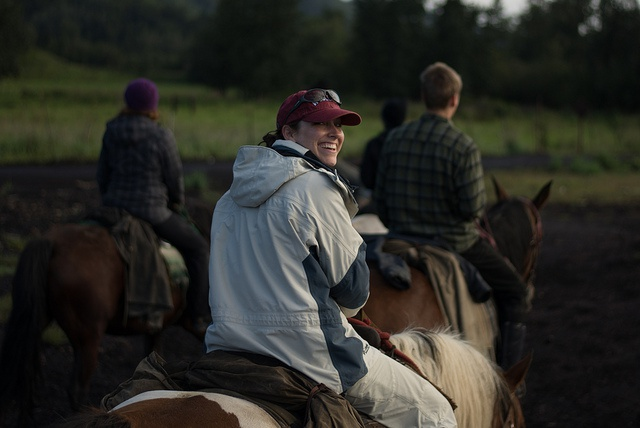Describe the objects in this image and their specific colors. I can see people in black, gray, darkgray, and blue tones, horse in black, gray, and darkgreen tones, horse in black and gray tones, people in black and gray tones, and horse in black, tan, and gray tones in this image. 